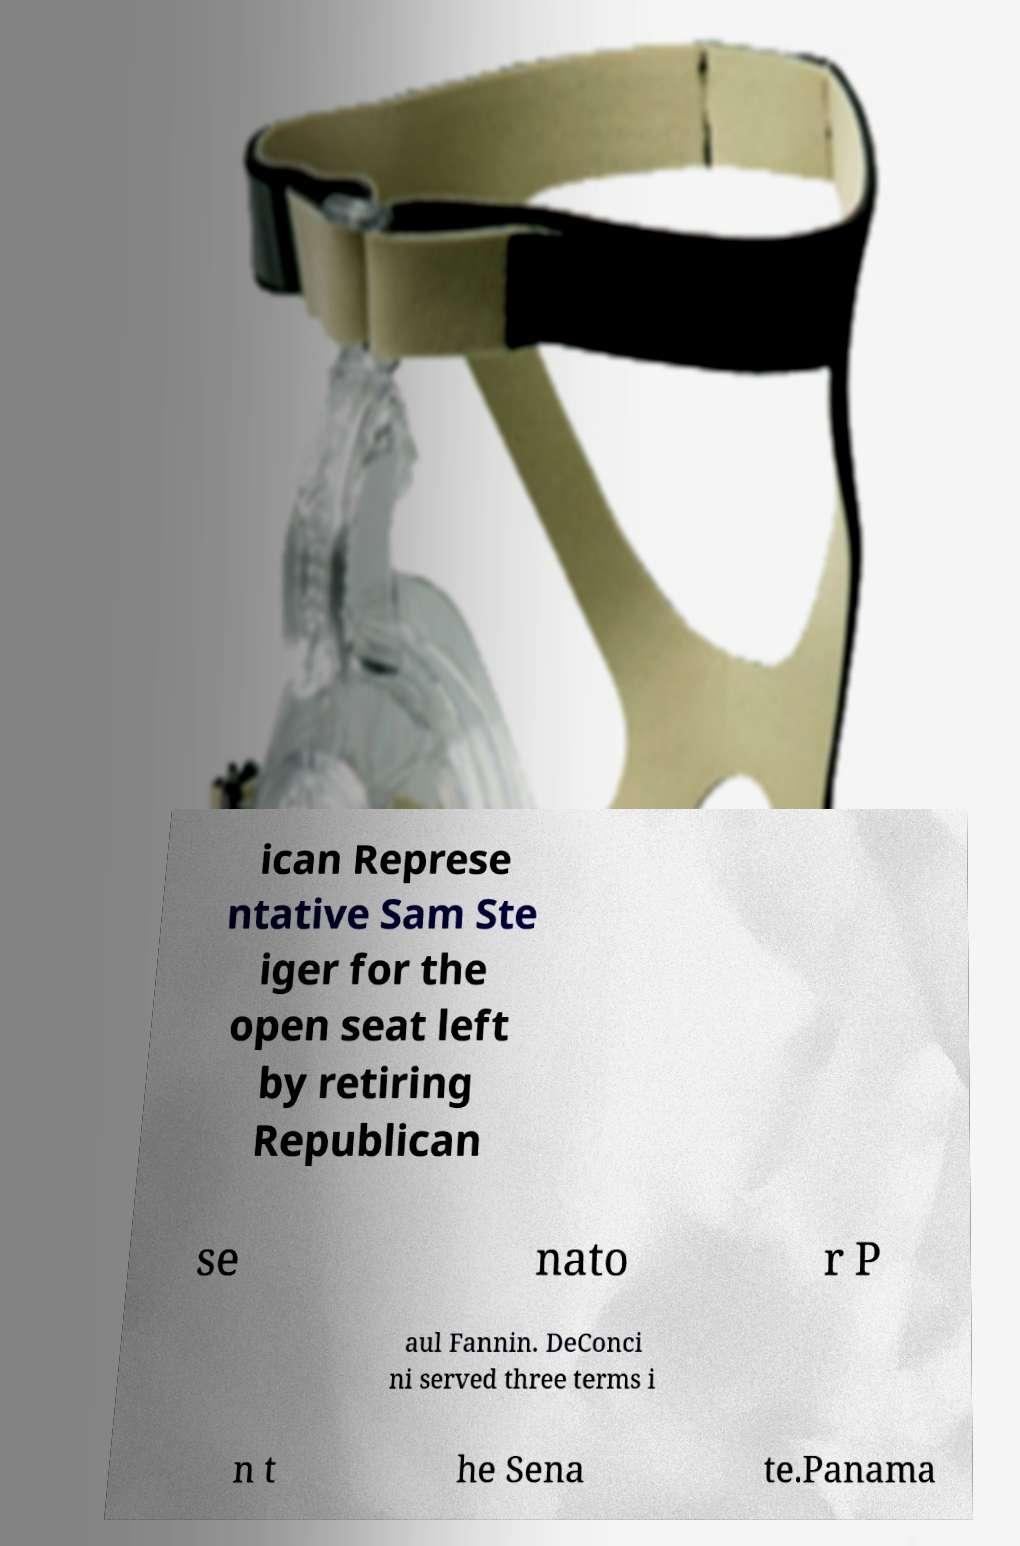I need the written content from this picture converted into text. Can you do that? ican Represe ntative Sam Ste iger for the open seat left by retiring Republican se nato r P aul Fannin. DeConci ni served three terms i n t he Sena te.Panama 